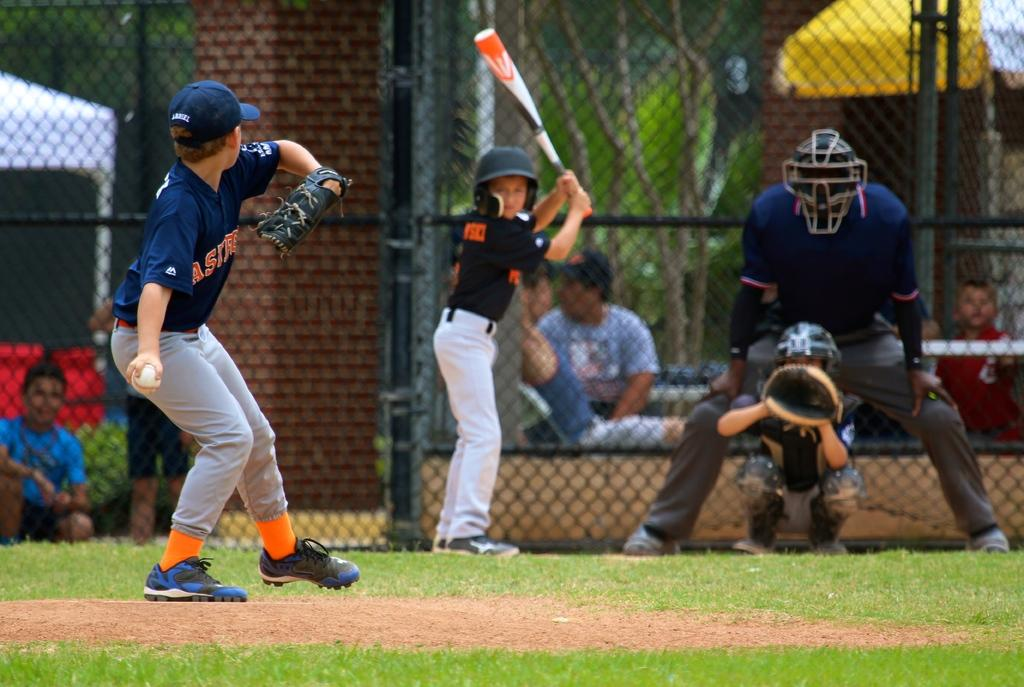<image>
Give a short and clear explanation of the subsequent image. a boy in an Astros jersey in about to throw a pitch 